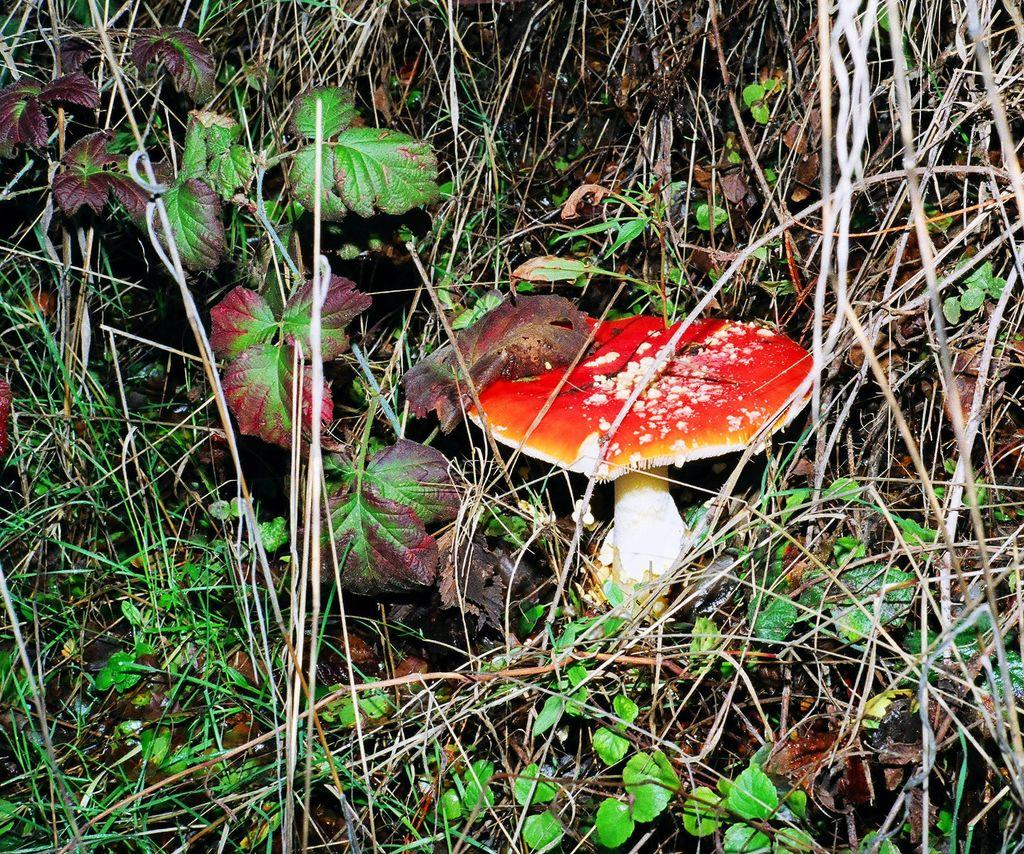What is the main subject in the foreground of the image? There is a mushroom in the foreground of the image. What other elements can be seen in the foreground of the image? There are plants and grass in the foreground of the image. Can you describe the flock of birds flying over the mushroom in the image? There are no birds or flock visible in the image; it only features a mushroom, plants, and grass in the foreground. 